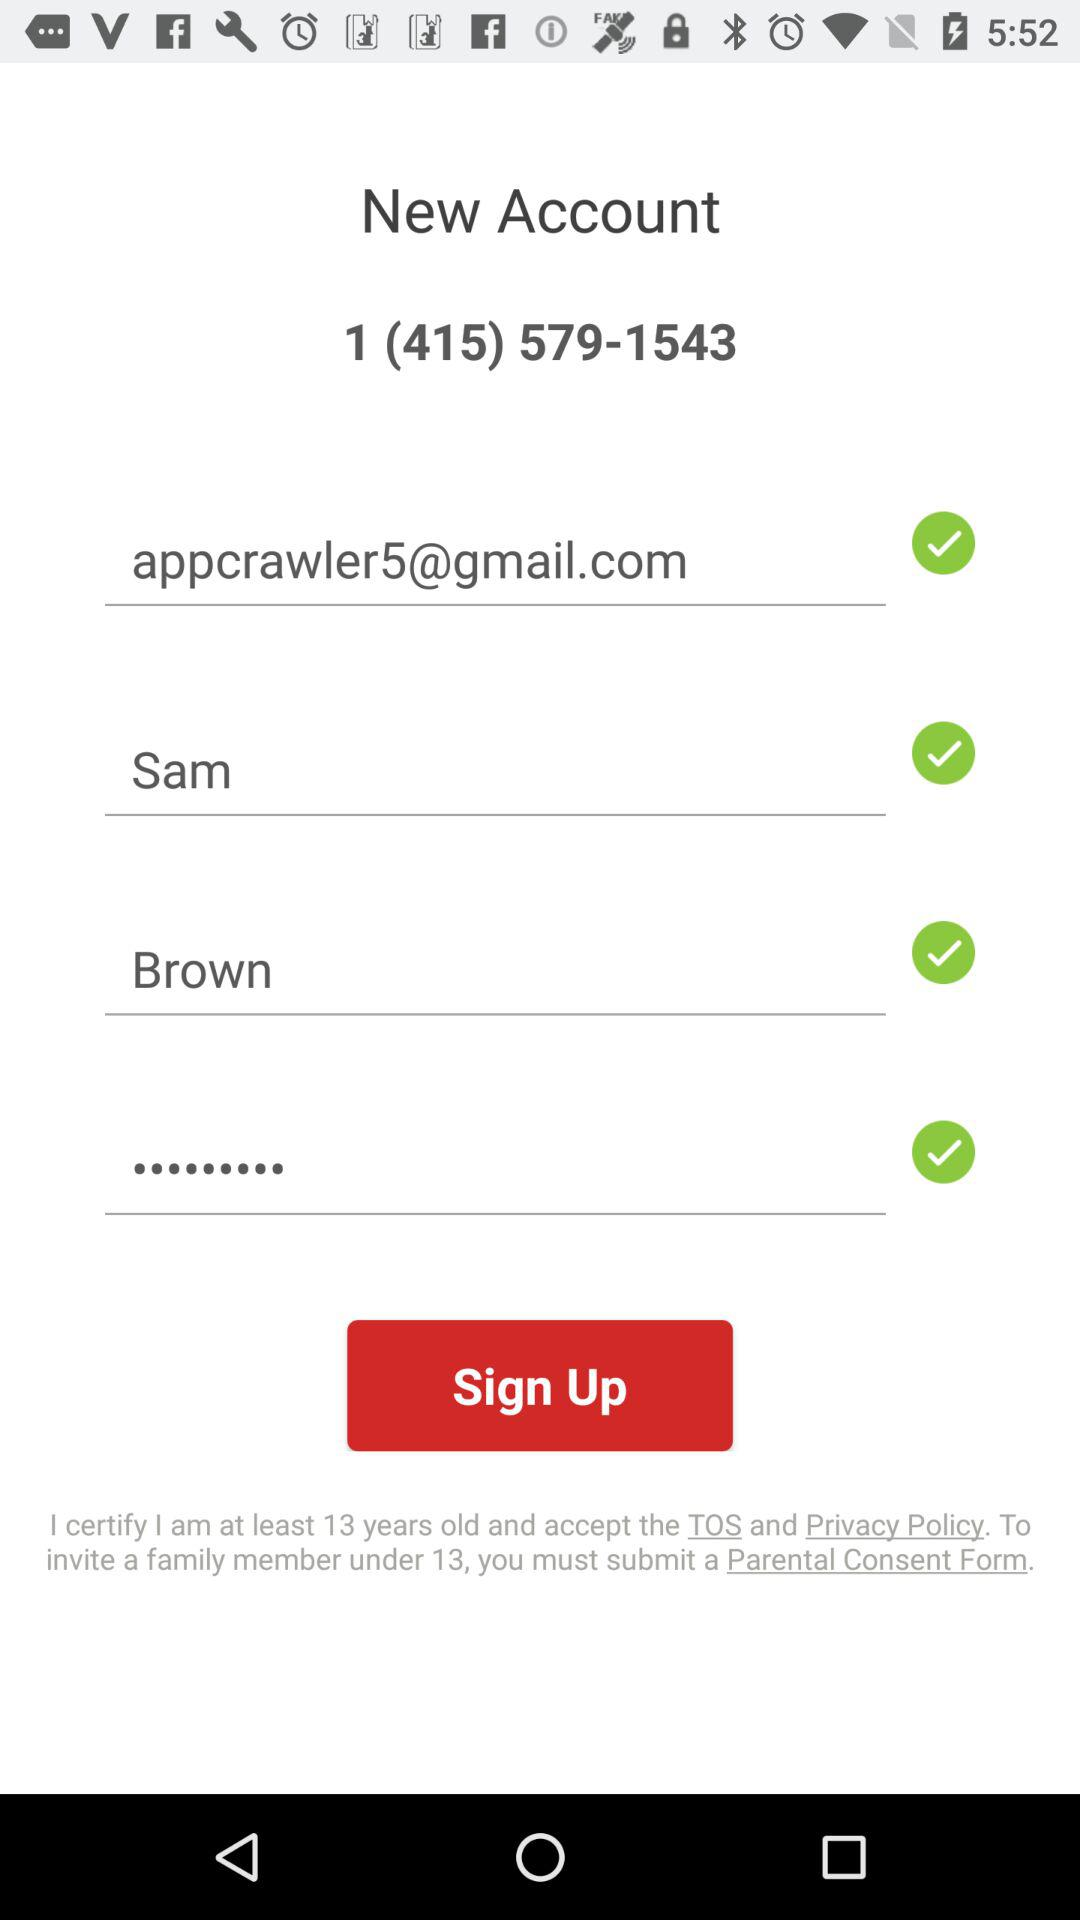What is the first name? The first name is Sam. 